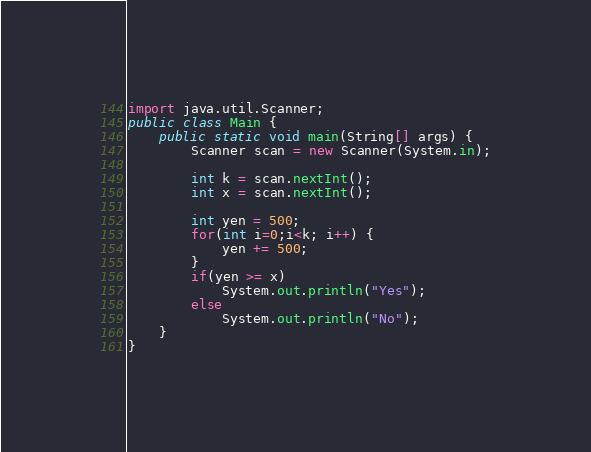Convert code to text. <code><loc_0><loc_0><loc_500><loc_500><_Java_>import java.util.Scanner;
public class Main {
    public static void main(String[] args) {
        Scanner scan = new Scanner(System.in);
        
        int k = scan.nextInt();
        int x = scan.nextInt();
        
        int yen = 500;
        for(int i=0;i<k; i++) {
            yen += 500;
        }
        if(yen >= x)
            System.out.println("Yes");
        else
            System.out.println("No");
    }
}</code> 